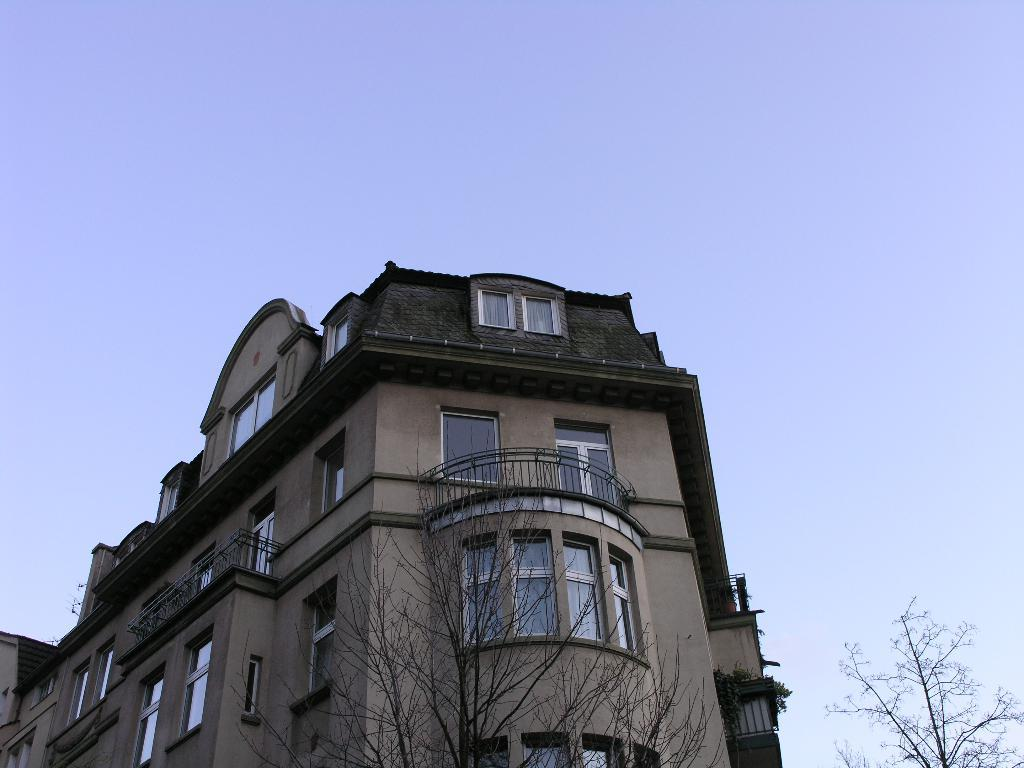What type of vegetation is present in the image? There are dry trees in the image. What structure can be seen at the bottom of the image? There is a building at the bottom of the image. What color is the sky in the background of the image? The sky is blue in the background of the image. What type of plate is visible on the top of the building in the image? There is no plate visible on the top of the building in the image. Are there any straws present in the image? There are no straws present in the image. 